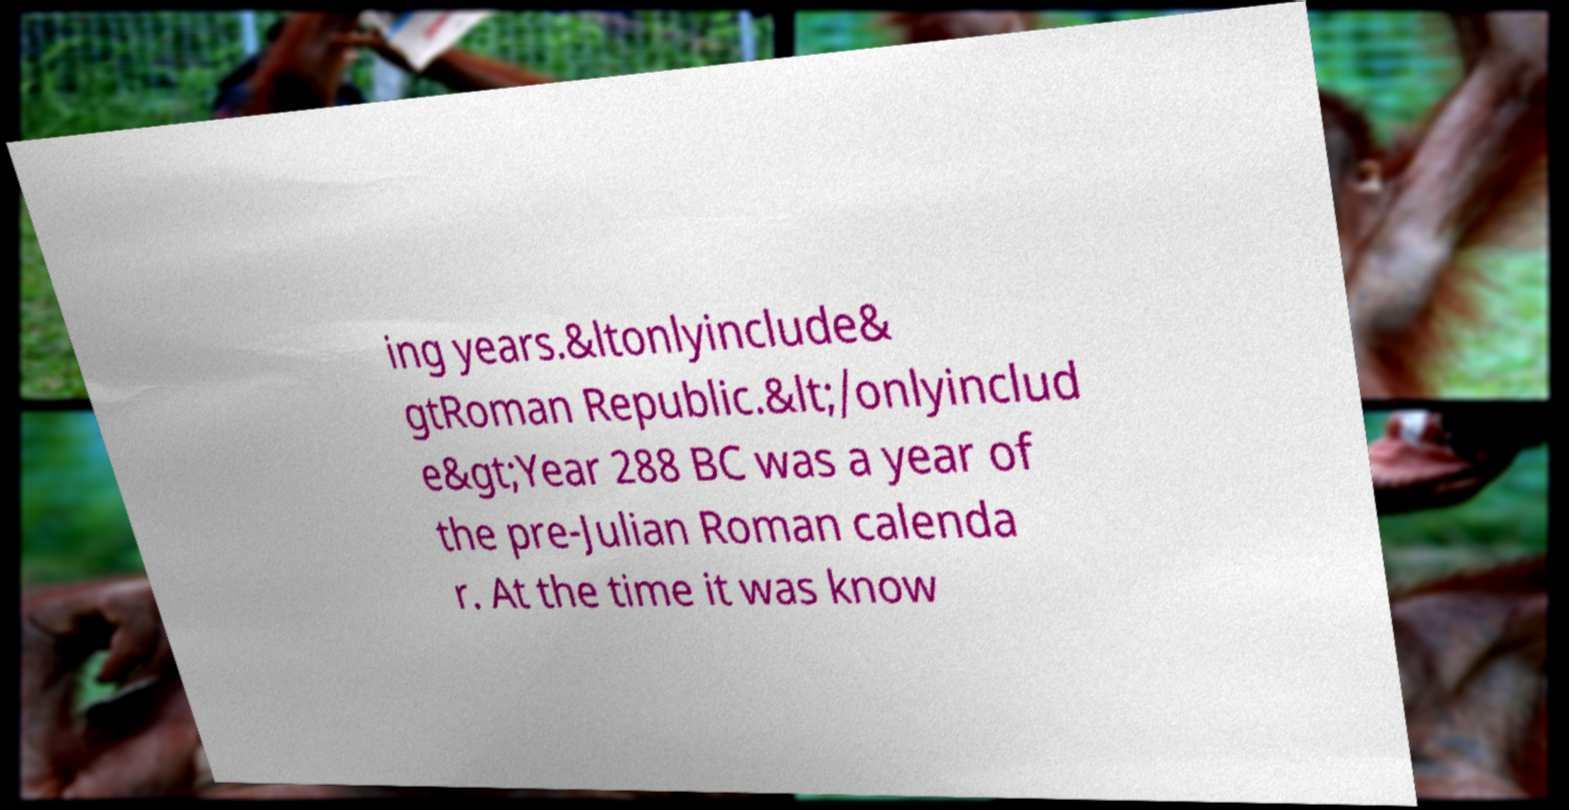There's text embedded in this image that I need extracted. Can you transcribe it verbatim? ing years.&ltonlyinclude& gtRoman Republic.&lt;/onlyinclud e&gt;Year 288 BC was a year of the pre-Julian Roman calenda r. At the time it was know 